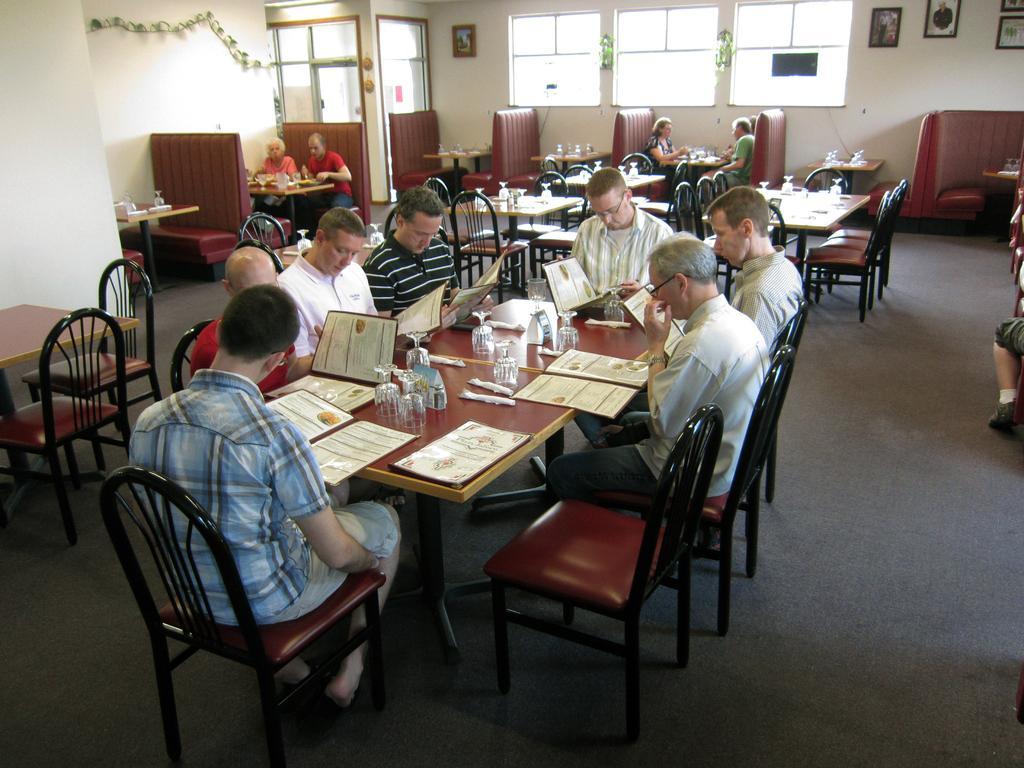Can you describe this image briefly? Person sitting around the table in the chair ,on the table there is glass,book,backside there are photo frame,window,wall. 